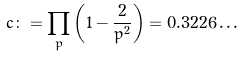<formula> <loc_0><loc_0><loc_500><loc_500>c \colon = \prod _ { p } \left ( 1 - \frac { 2 } { p ^ { 2 } } \right ) = 0 . 3 2 2 6 \dots</formula> 